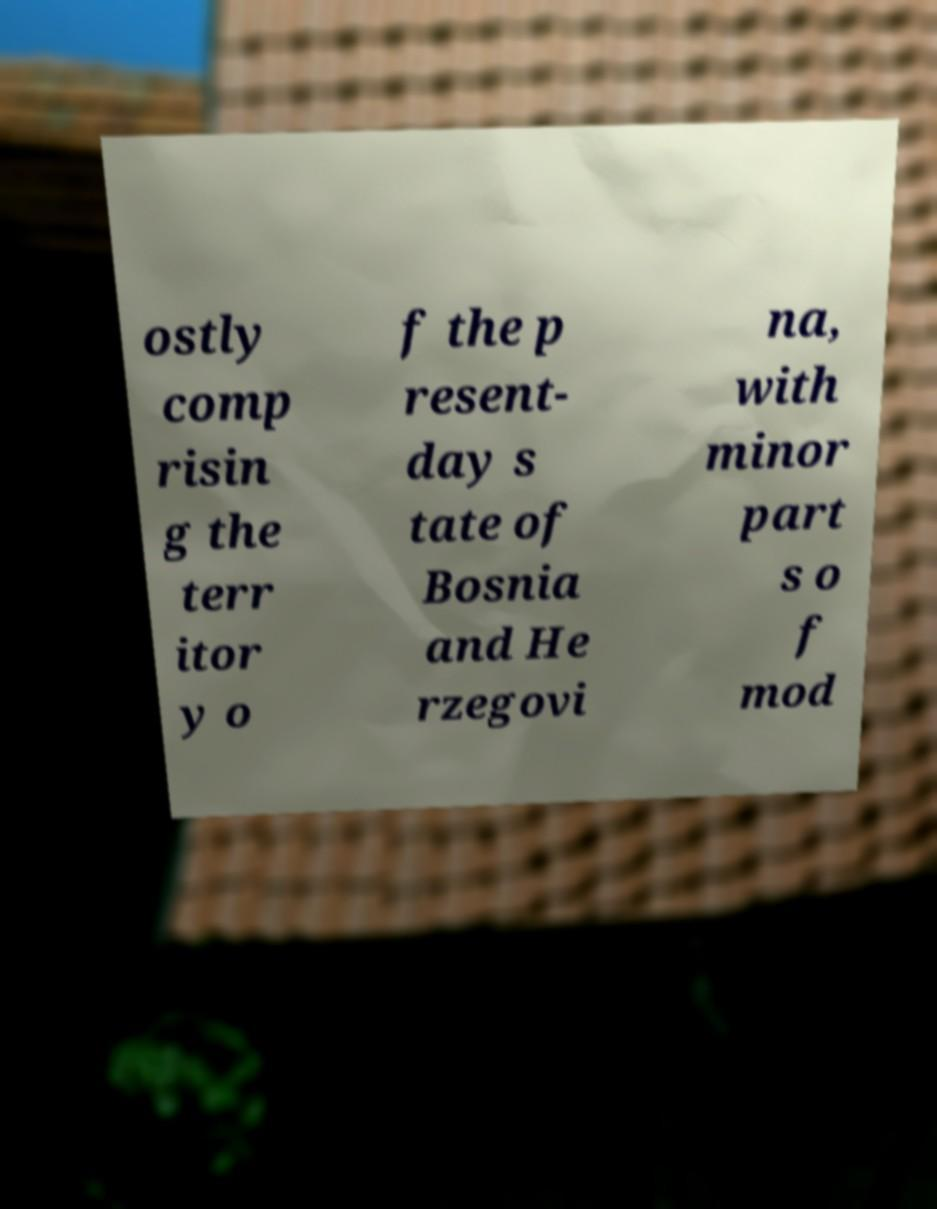I need the written content from this picture converted into text. Can you do that? ostly comp risin g the terr itor y o f the p resent- day s tate of Bosnia and He rzegovi na, with minor part s o f mod 